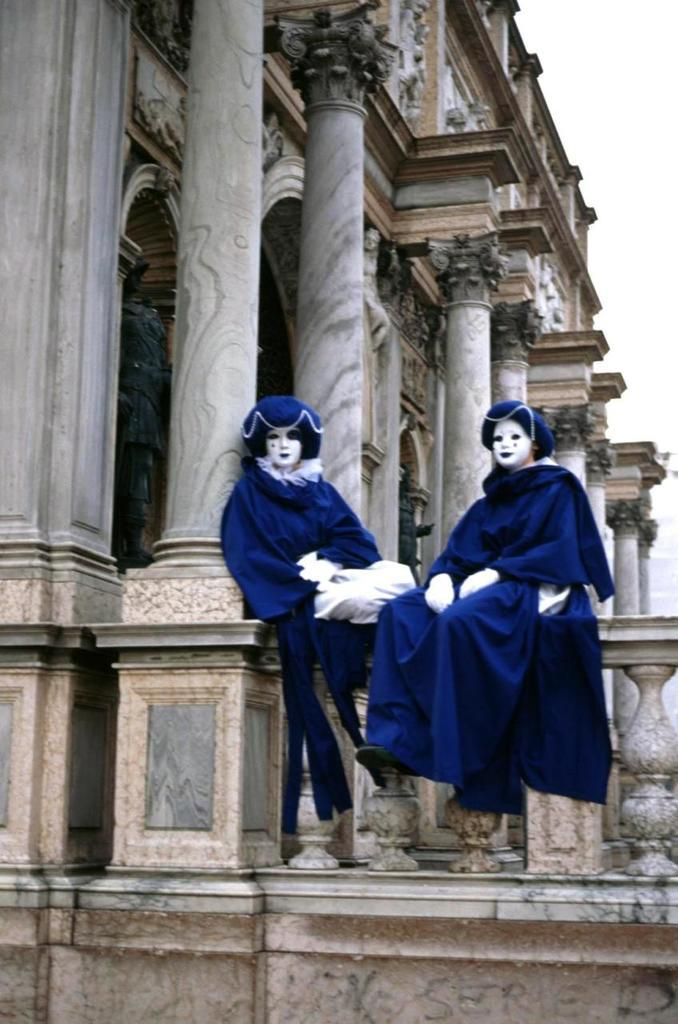What are the people in the image wearing? The people in the image are wearing fancy dress. Where are the people sitting in the image? The people are sitting on a wall. What can be seen in the background of the image? There is a building visible in the image. What is visible above the people and the wall in the image? The sky is visible in the image. What type of range can be seen in the image? There is no range present in the image; it features people wearing fancy dress sitting on a wall with a building and the sky visible in the background. 